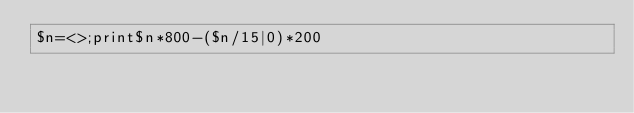Convert code to text. <code><loc_0><loc_0><loc_500><loc_500><_Perl_>$n=<>;print$n*800-($n/15|0)*200</code> 